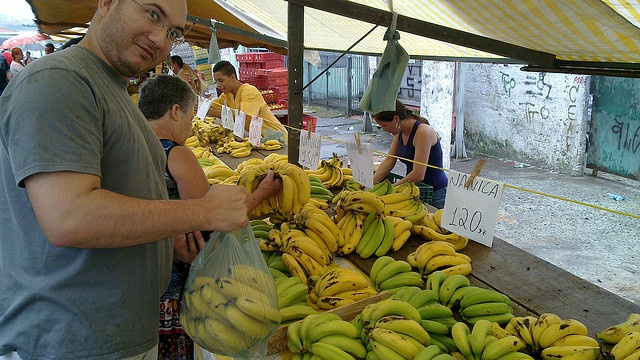Describe the objects in this image and their specific colors. I can see people in white, gray, and black tones, banana in white, olive, and black tones, people in white, black, brown, and gray tones, banana in white, olive, and gray tones, and people in white, black, maroon, gray, and brown tones in this image. 